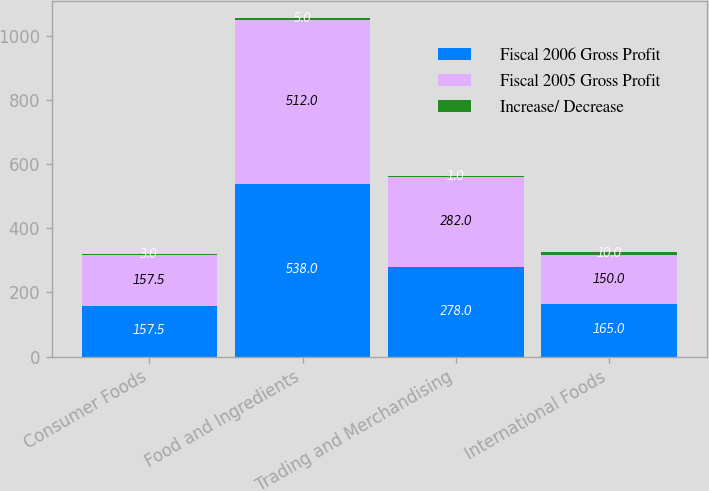Convert chart to OTSL. <chart><loc_0><loc_0><loc_500><loc_500><stacked_bar_chart><ecel><fcel>Consumer Foods<fcel>Food and Ingredients<fcel>Trading and Merchandising<fcel>International Foods<nl><fcel>Fiscal 2006 Gross Profit<fcel>157.5<fcel>538<fcel>278<fcel>165<nl><fcel>Fiscal 2005 Gross Profit<fcel>157.5<fcel>512<fcel>282<fcel>150<nl><fcel>Increase/ Decrease<fcel>3<fcel>5<fcel>1<fcel>10<nl></chart> 